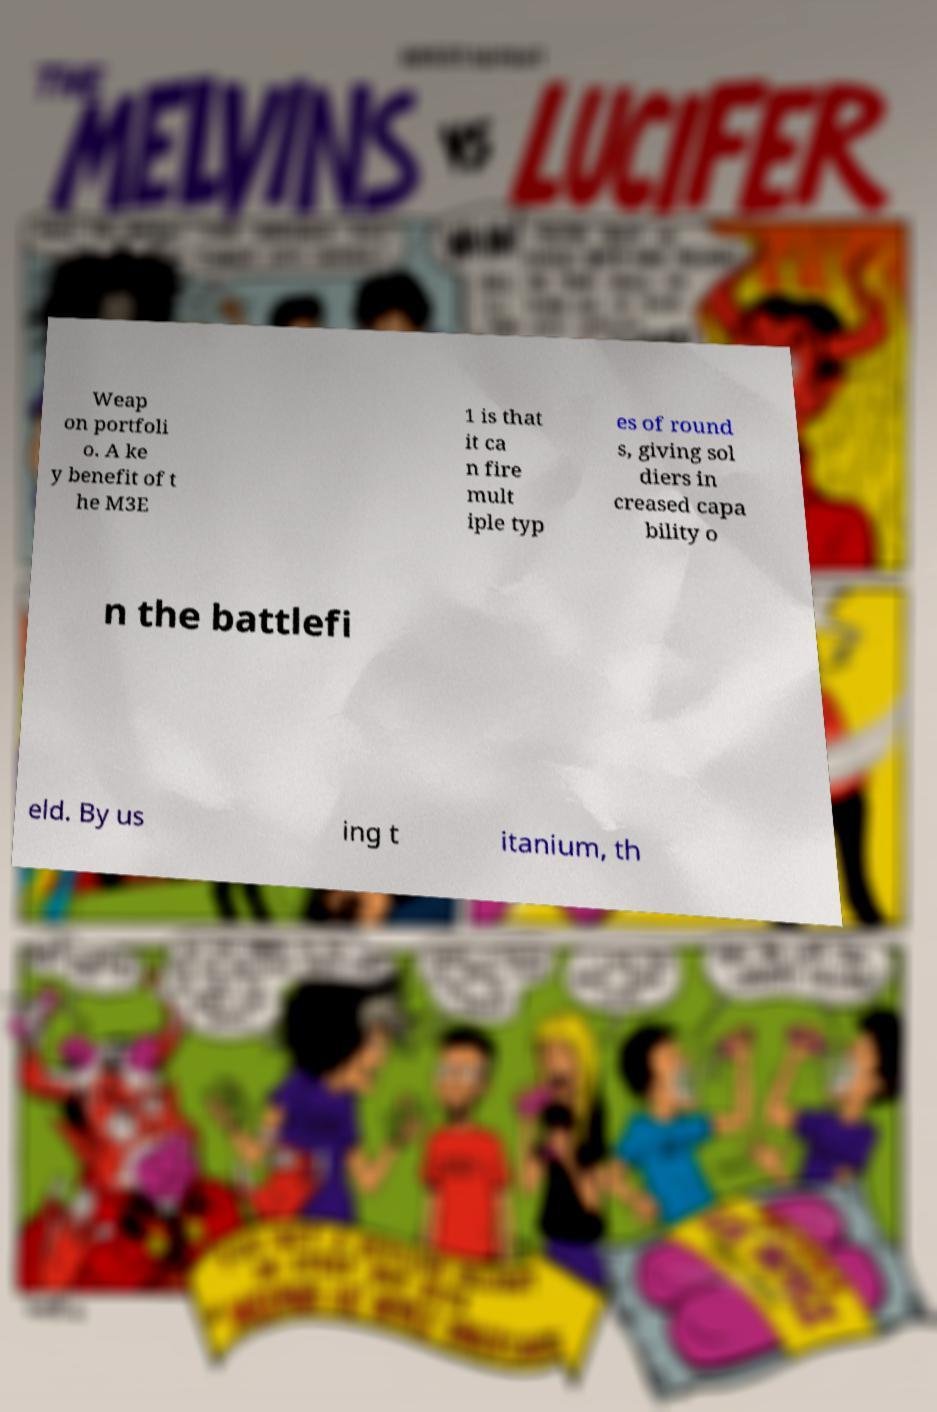Please identify and transcribe the text found in this image. Weap on portfoli o. A ke y benefit of t he M3E 1 is that it ca n fire mult iple typ es of round s, giving sol diers in creased capa bility o n the battlefi eld. By us ing t itanium, th 